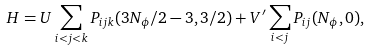Convert formula to latex. <formula><loc_0><loc_0><loc_500><loc_500>H = U \sum _ { i < j < k } P _ { i j k } ( 3 N _ { \phi } / 2 - 3 , 3 / 2 ) + V ^ { \prime } \sum _ { i < j } P _ { i j } ( N _ { \phi } , 0 ) ,</formula> 